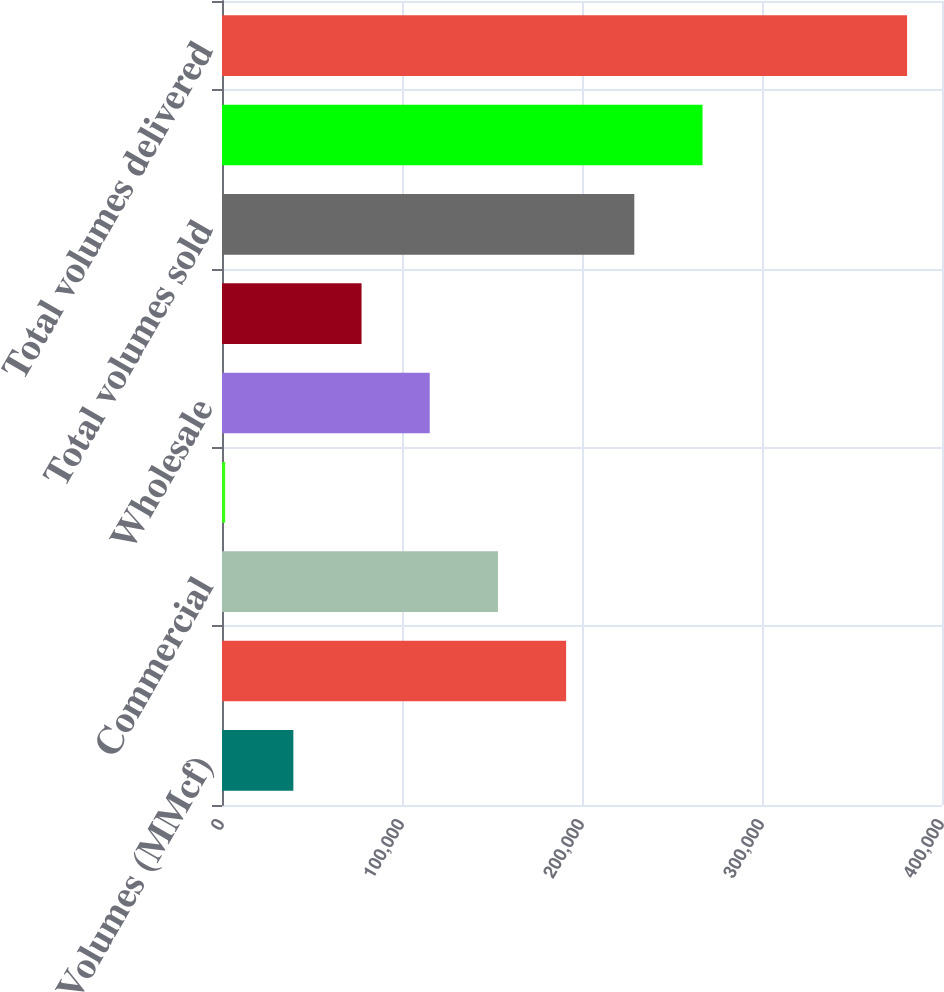<chart> <loc_0><loc_0><loc_500><loc_500><bar_chart><fcel>Volumes (MMcf)<fcel>Residential<fcel>Commercial<fcel>Industrial<fcel>Wholesale<fcel>Public Authority<fcel>Total volumes sold<fcel>Transportation<fcel>Total volumes delivered<nl><fcel>39642.1<fcel>191178<fcel>153294<fcel>1758<fcel>115410<fcel>77526.2<fcel>229063<fcel>266947<fcel>380599<nl></chart> 